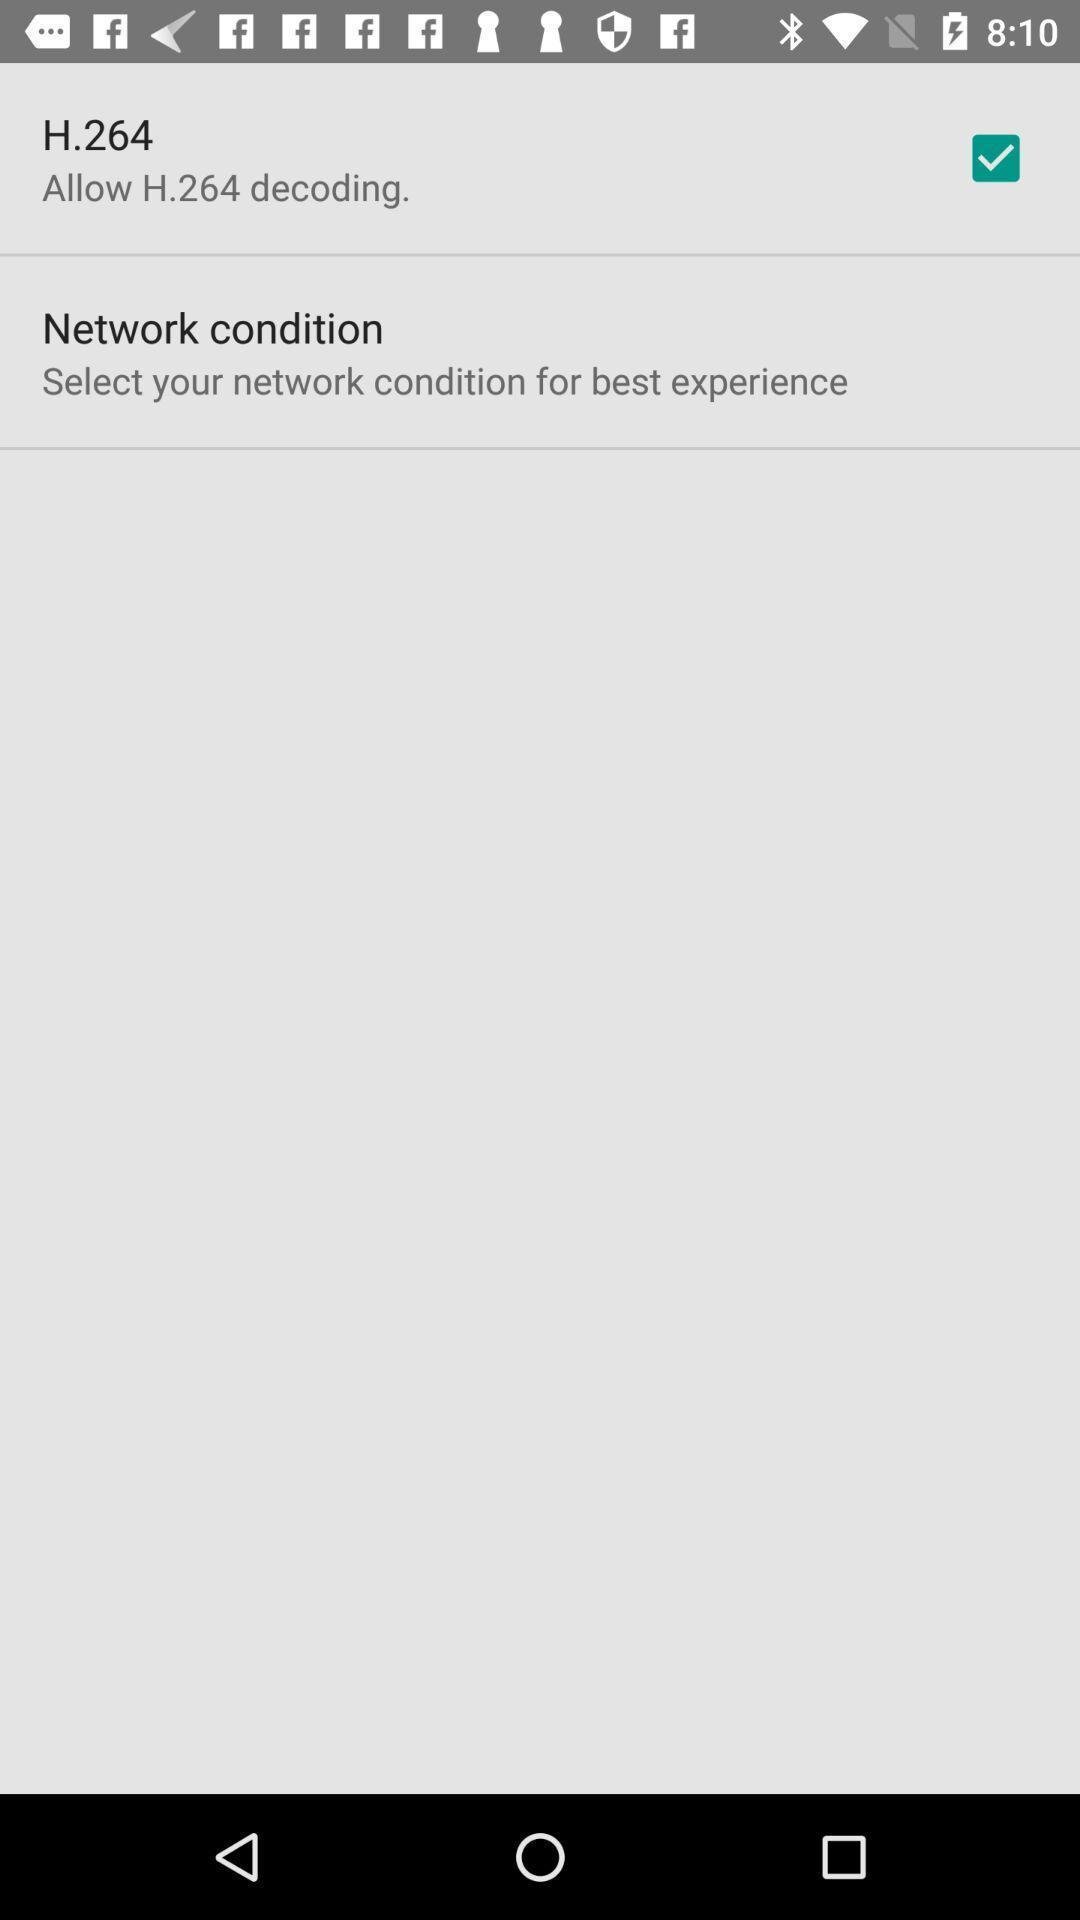Describe the content in this image. Screen shows about network conditions. 